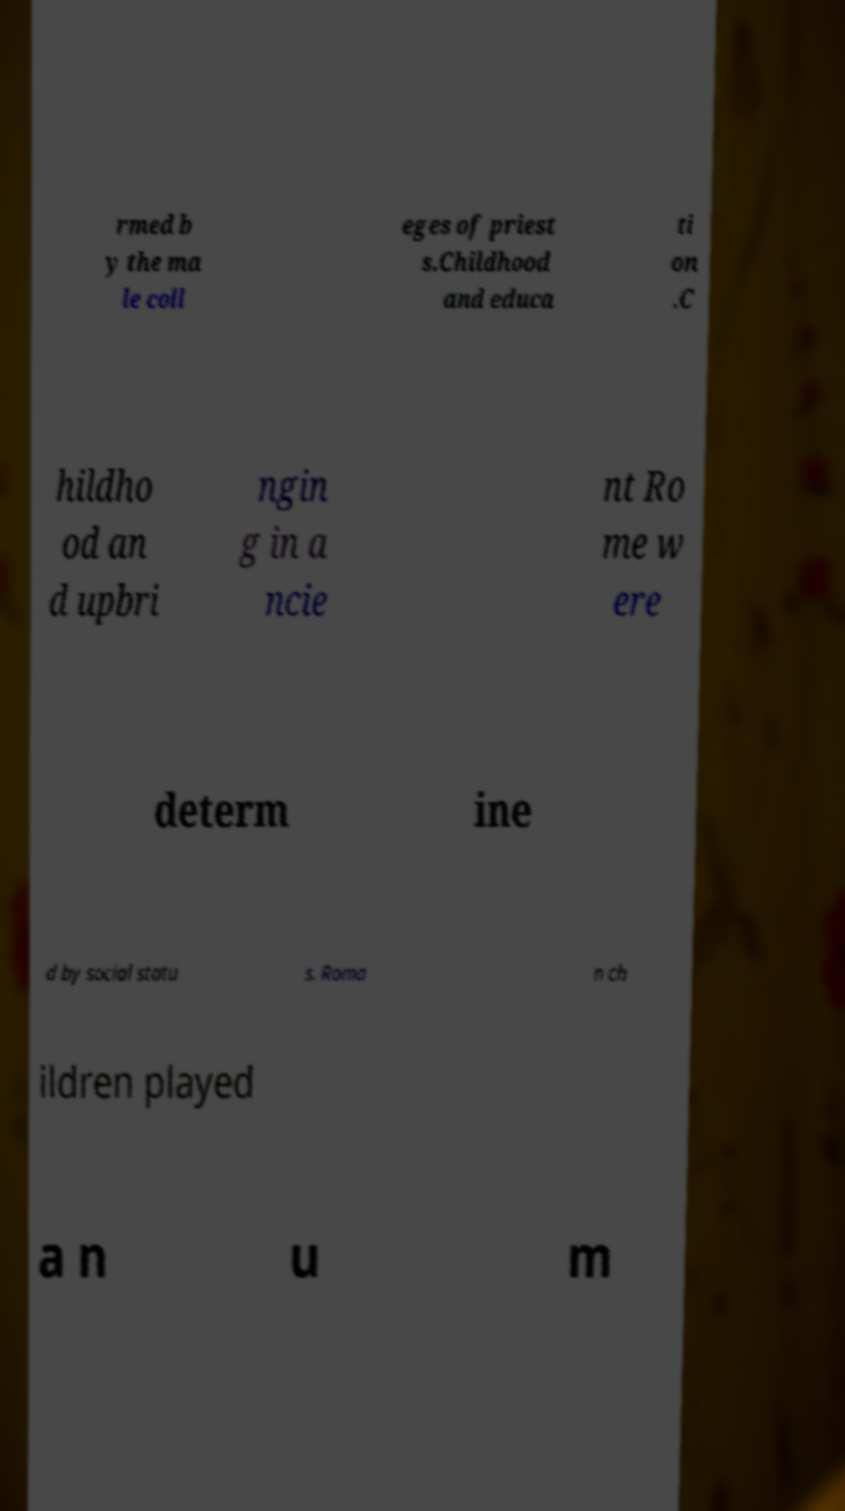I need the written content from this picture converted into text. Can you do that? rmed b y the ma le coll eges of priest s.Childhood and educa ti on .C hildho od an d upbri ngin g in a ncie nt Ro me w ere determ ine d by social statu s. Roma n ch ildren played a n u m 